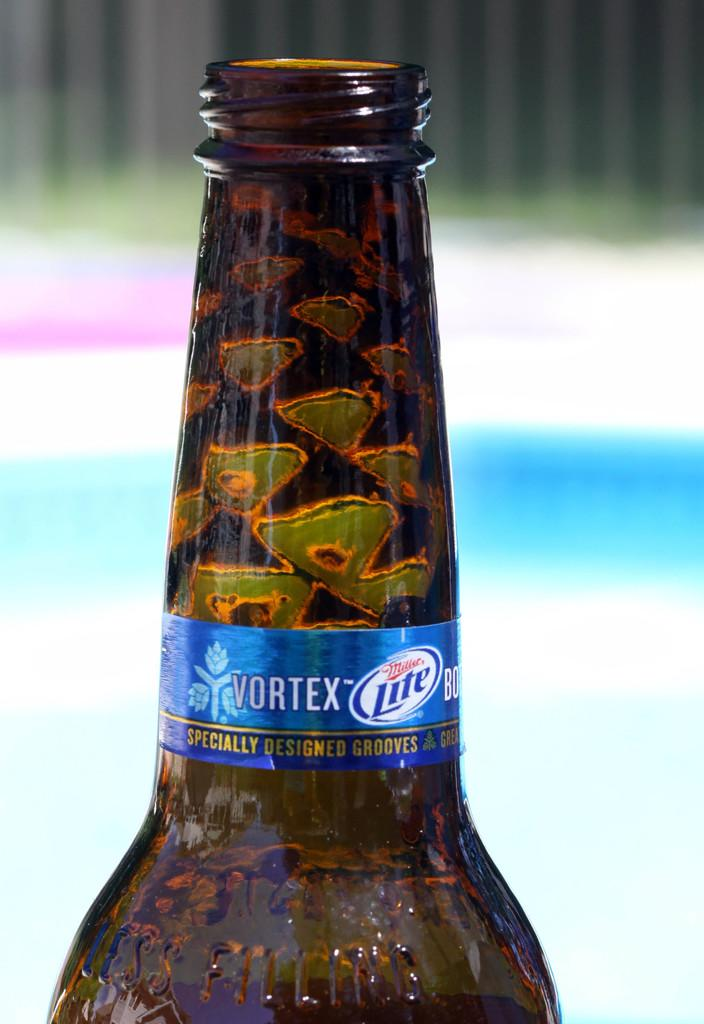<image>
Write a terse but informative summary of the picture. The top of a Miller Lite Vortex bottle has specially designed grooves. 